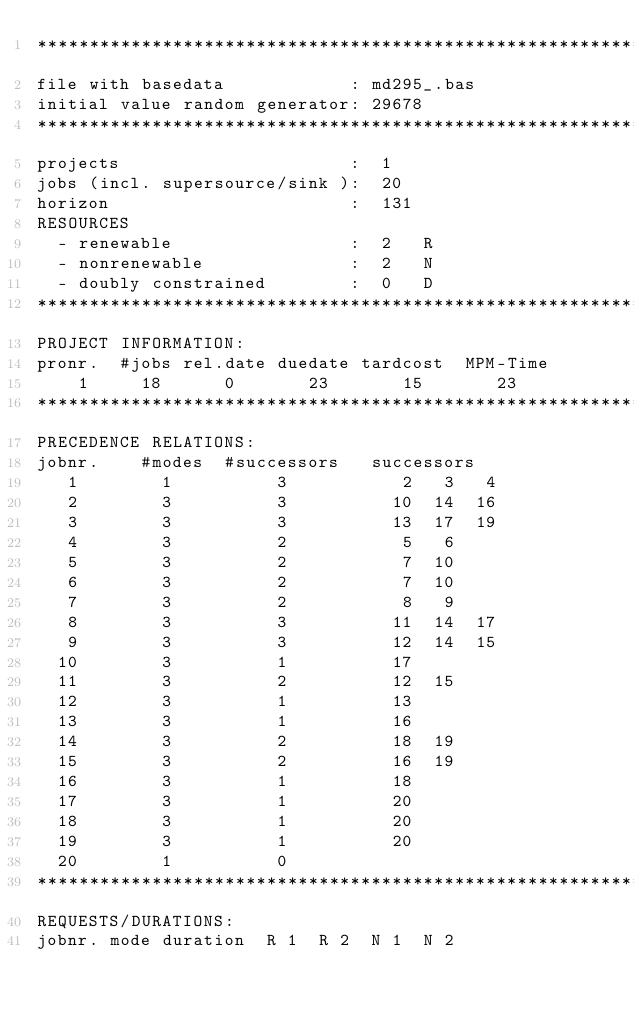Convert code to text. <code><loc_0><loc_0><loc_500><loc_500><_ObjectiveC_>************************************************************************
file with basedata            : md295_.bas
initial value random generator: 29678
************************************************************************
projects                      :  1
jobs (incl. supersource/sink ):  20
horizon                       :  131
RESOURCES
  - renewable                 :  2   R
  - nonrenewable              :  2   N
  - doubly constrained        :  0   D
************************************************************************
PROJECT INFORMATION:
pronr.  #jobs rel.date duedate tardcost  MPM-Time
    1     18      0       23       15       23
************************************************************************
PRECEDENCE RELATIONS:
jobnr.    #modes  #successors   successors
   1        1          3           2   3   4
   2        3          3          10  14  16
   3        3          3          13  17  19
   4        3          2           5   6
   5        3          2           7  10
   6        3          2           7  10
   7        3          2           8   9
   8        3          3          11  14  17
   9        3          3          12  14  15
  10        3          1          17
  11        3          2          12  15
  12        3          1          13
  13        3          1          16
  14        3          2          18  19
  15        3          2          16  19
  16        3          1          18
  17        3          1          20
  18        3          1          20
  19        3          1          20
  20        1          0        
************************************************************************
REQUESTS/DURATIONS:
jobnr. mode duration  R 1  R 2  N 1  N 2</code> 